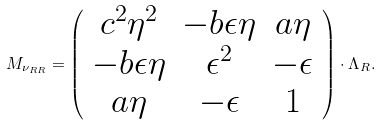Convert formula to latex. <formula><loc_0><loc_0><loc_500><loc_500>M _ { \nu _ { R R } } = \left ( \begin{array} { c c c } c ^ { 2 } \eta ^ { 2 } & - b \epsilon \eta & a \eta \\ - b \epsilon \eta & \epsilon ^ { 2 } & - \epsilon \\ a \eta & - \epsilon & 1 \end{array} \right ) \cdot \Lambda _ { R } .</formula> 